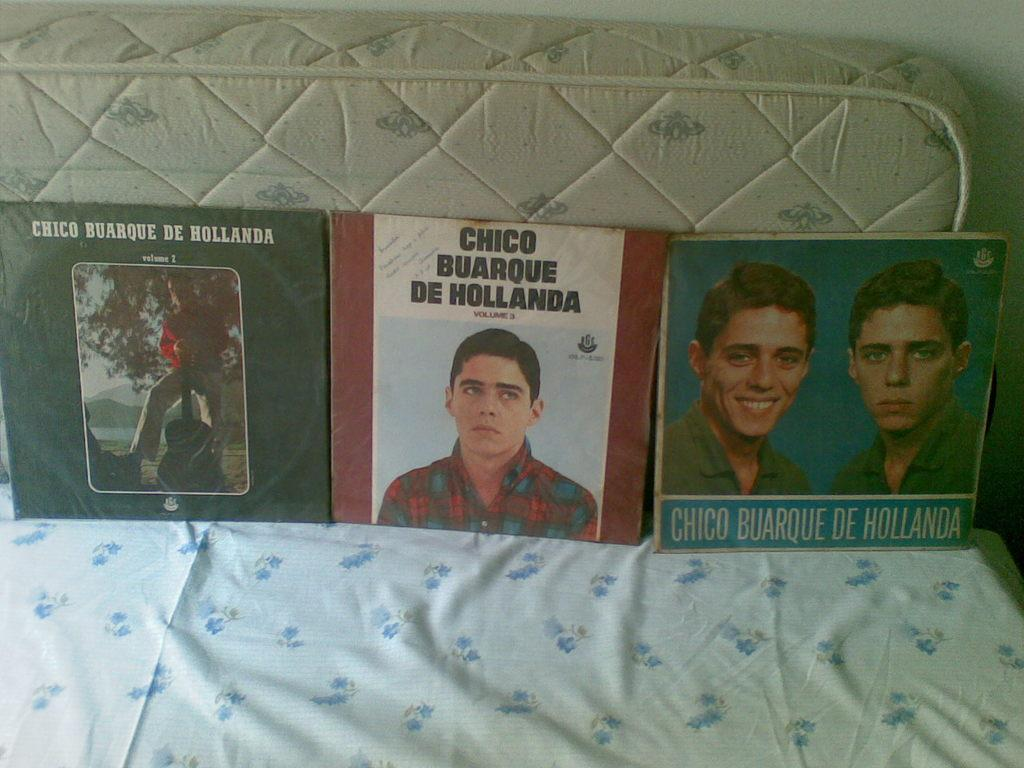What objects are present in the image? There are books in the image. How are the books arranged or placed? The books are placed on a cloth. What can be seen in the background of the image? There is a mattress and a wall in the background of the image. What type of mist can be seen surrounding the mountain in the image? There is no mist or mountain present in the image; it features books placed on a cloth with a mattress and a wall in the background. 